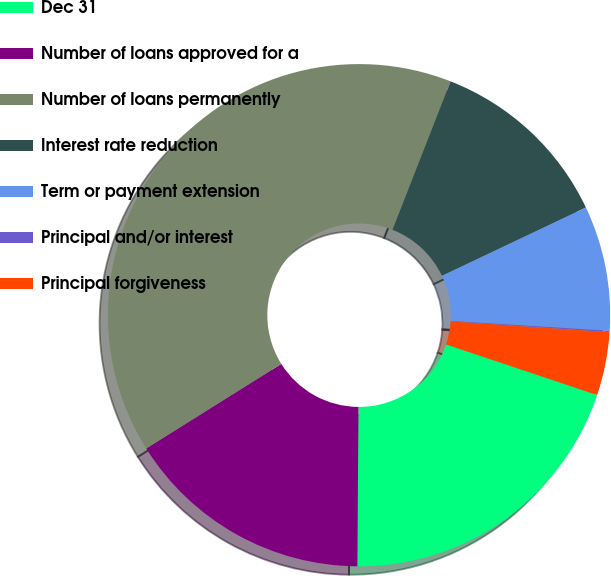<chart> <loc_0><loc_0><loc_500><loc_500><pie_chart><fcel>Dec 31<fcel>Number of loans approved for a<fcel>Number of loans permanently<fcel>Interest rate reduction<fcel>Term or payment extension<fcel>Principal and/or interest<fcel>Principal forgiveness<nl><fcel>19.96%<fcel>15.99%<fcel>39.84%<fcel>12.01%<fcel>8.04%<fcel>0.09%<fcel>4.07%<nl></chart> 